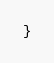Convert code to text. <code><loc_0><loc_0><loc_500><loc_500><_CSS_>}</code> 